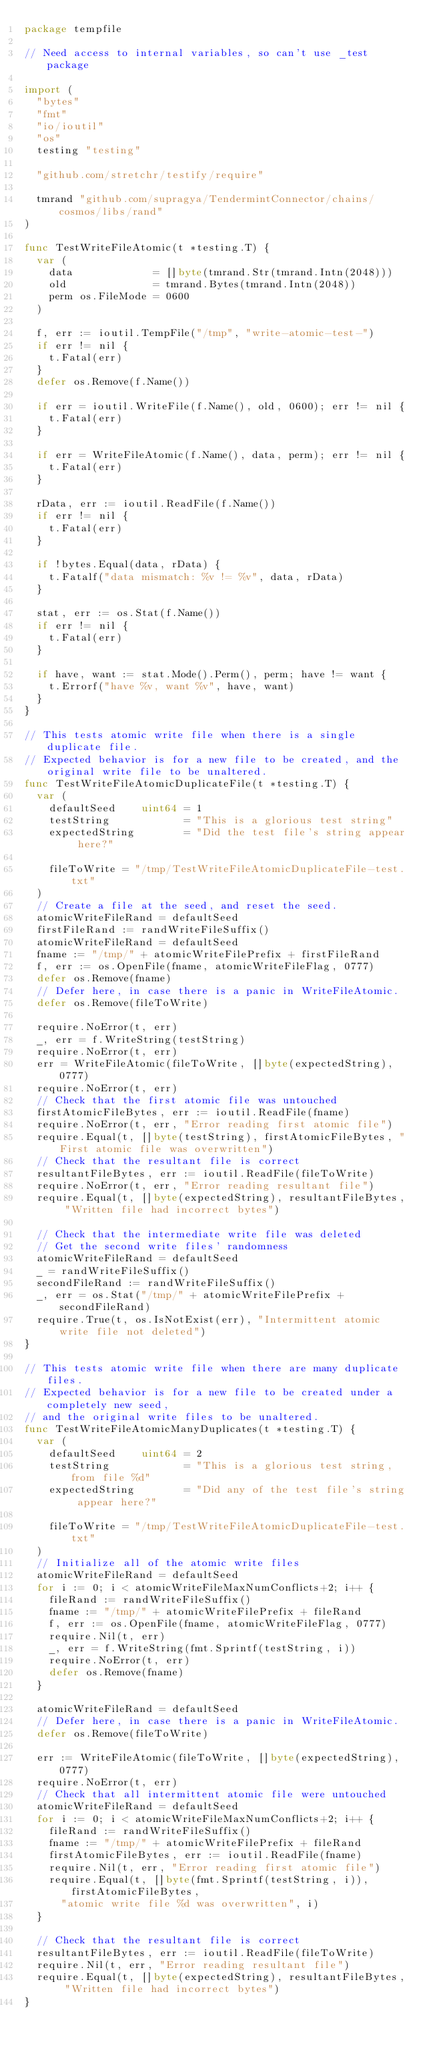<code> <loc_0><loc_0><loc_500><loc_500><_Go_>package tempfile

// Need access to internal variables, so can't use _test package

import (
	"bytes"
	"fmt"
	"io/ioutil"
	"os"
	testing "testing"

	"github.com/stretchr/testify/require"

	tmrand "github.com/supragya/TendermintConnector/chains/cosmos/libs/rand"
)

func TestWriteFileAtomic(t *testing.T) {
	var (
		data             = []byte(tmrand.Str(tmrand.Intn(2048)))
		old              = tmrand.Bytes(tmrand.Intn(2048))
		perm os.FileMode = 0600
	)

	f, err := ioutil.TempFile("/tmp", "write-atomic-test-")
	if err != nil {
		t.Fatal(err)
	}
	defer os.Remove(f.Name())

	if err = ioutil.WriteFile(f.Name(), old, 0600); err != nil {
		t.Fatal(err)
	}

	if err = WriteFileAtomic(f.Name(), data, perm); err != nil {
		t.Fatal(err)
	}

	rData, err := ioutil.ReadFile(f.Name())
	if err != nil {
		t.Fatal(err)
	}

	if !bytes.Equal(data, rData) {
		t.Fatalf("data mismatch: %v != %v", data, rData)
	}

	stat, err := os.Stat(f.Name())
	if err != nil {
		t.Fatal(err)
	}

	if have, want := stat.Mode().Perm(), perm; have != want {
		t.Errorf("have %v, want %v", have, want)
	}
}

// This tests atomic write file when there is a single duplicate file.
// Expected behavior is for a new file to be created, and the original write file to be unaltered.
func TestWriteFileAtomicDuplicateFile(t *testing.T) {
	var (
		defaultSeed    uint64 = 1
		testString            = "This is a glorious test string"
		expectedString        = "Did the test file's string appear here?"

		fileToWrite = "/tmp/TestWriteFileAtomicDuplicateFile-test.txt"
	)
	// Create a file at the seed, and reset the seed.
	atomicWriteFileRand = defaultSeed
	firstFileRand := randWriteFileSuffix()
	atomicWriteFileRand = defaultSeed
	fname := "/tmp/" + atomicWriteFilePrefix + firstFileRand
	f, err := os.OpenFile(fname, atomicWriteFileFlag, 0777)
	defer os.Remove(fname)
	// Defer here, in case there is a panic in WriteFileAtomic.
	defer os.Remove(fileToWrite)

	require.NoError(t, err)
	_, err = f.WriteString(testString)
	require.NoError(t, err)
	err = WriteFileAtomic(fileToWrite, []byte(expectedString), 0777)
	require.NoError(t, err)
	// Check that the first atomic file was untouched
	firstAtomicFileBytes, err := ioutil.ReadFile(fname)
	require.NoError(t, err, "Error reading first atomic file")
	require.Equal(t, []byte(testString), firstAtomicFileBytes, "First atomic file was overwritten")
	// Check that the resultant file is correct
	resultantFileBytes, err := ioutil.ReadFile(fileToWrite)
	require.NoError(t, err, "Error reading resultant file")
	require.Equal(t, []byte(expectedString), resultantFileBytes, "Written file had incorrect bytes")

	// Check that the intermediate write file was deleted
	// Get the second write files' randomness
	atomicWriteFileRand = defaultSeed
	_ = randWriteFileSuffix()
	secondFileRand := randWriteFileSuffix()
	_, err = os.Stat("/tmp/" + atomicWriteFilePrefix + secondFileRand)
	require.True(t, os.IsNotExist(err), "Intermittent atomic write file not deleted")
}

// This tests atomic write file when there are many duplicate files.
// Expected behavior is for a new file to be created under a completely new seed,
// and the original write files to be unaltered.
func TestWriteFileAtomicManyDuplicates(t *testing.T) {
	var (
		defaultSeed    uint64 = 2
		testString            = "This is a glorious test string, from file %d"
		expectedString        = "Did any of the test file's string appear here?"

		fileToWrite = "/tmp/TestWriteFileAtomicDuplicateFile-test.txt"
	)
	// Initialize all of the atomic write files
	atomicWriteFileRand = defaultSeed
	for i := 0; i < atomicWriteFileMaxNumConflicts+2; i++ {
		fileRand := randWriteFileSuffix()
		fname := "/tmp/" + atomicWriteFilePrefix + fileRand
		f, err := os.OpenFile(fname, atomicWriteFileFlag, 0777)
		require.Nil(t, err)
		_, err = f.WriteString(fmt.Sprintf(testString, i))
		require.NoError(t, err)
		defer os.Remove(fname)
	}

	atomicWriteFileRand = defaultSeed
	// Defer here, in case there is a panic in WriteFileAtomic.
	defer os.Remove(fileToWrite)

	err := WriteFileAtomic(fileToWrite, []byte(expectedString), 0777)
	require.NoError(t, err)
	// Check that all intermittent atomic file were untouched
	atomicWriteFileRand = defaultSeed
	for i := 0; i < atomicWriteFileMaxNumConflicts+2; i++ {
		fileRand := randWriteFileSuffix()
		fname := "/tmp/" + atomicWriteFilePrefix + fileRand
		firstAtomicFileBytes, err := ioutil.ReadFile(fname)
		require.Nil(t, err, "Error reading first atomic file")
		require.Equal(t, []byte(fmt.Sprintf(testString, i)), firstAtomicFileBytes,
			"atomic write file %d was overwritten", i)
	}

	// Check that the resultant file is correct
	resultantFileBytes, err := ioutil.ReadFile(fileToWrite)
	require.Nil(t, err, "Error reading resultant file")
	require.Equal(t, []byte(expectedString), resultantFileBytes, "Written file had incorrect bytes")
}
</code> 